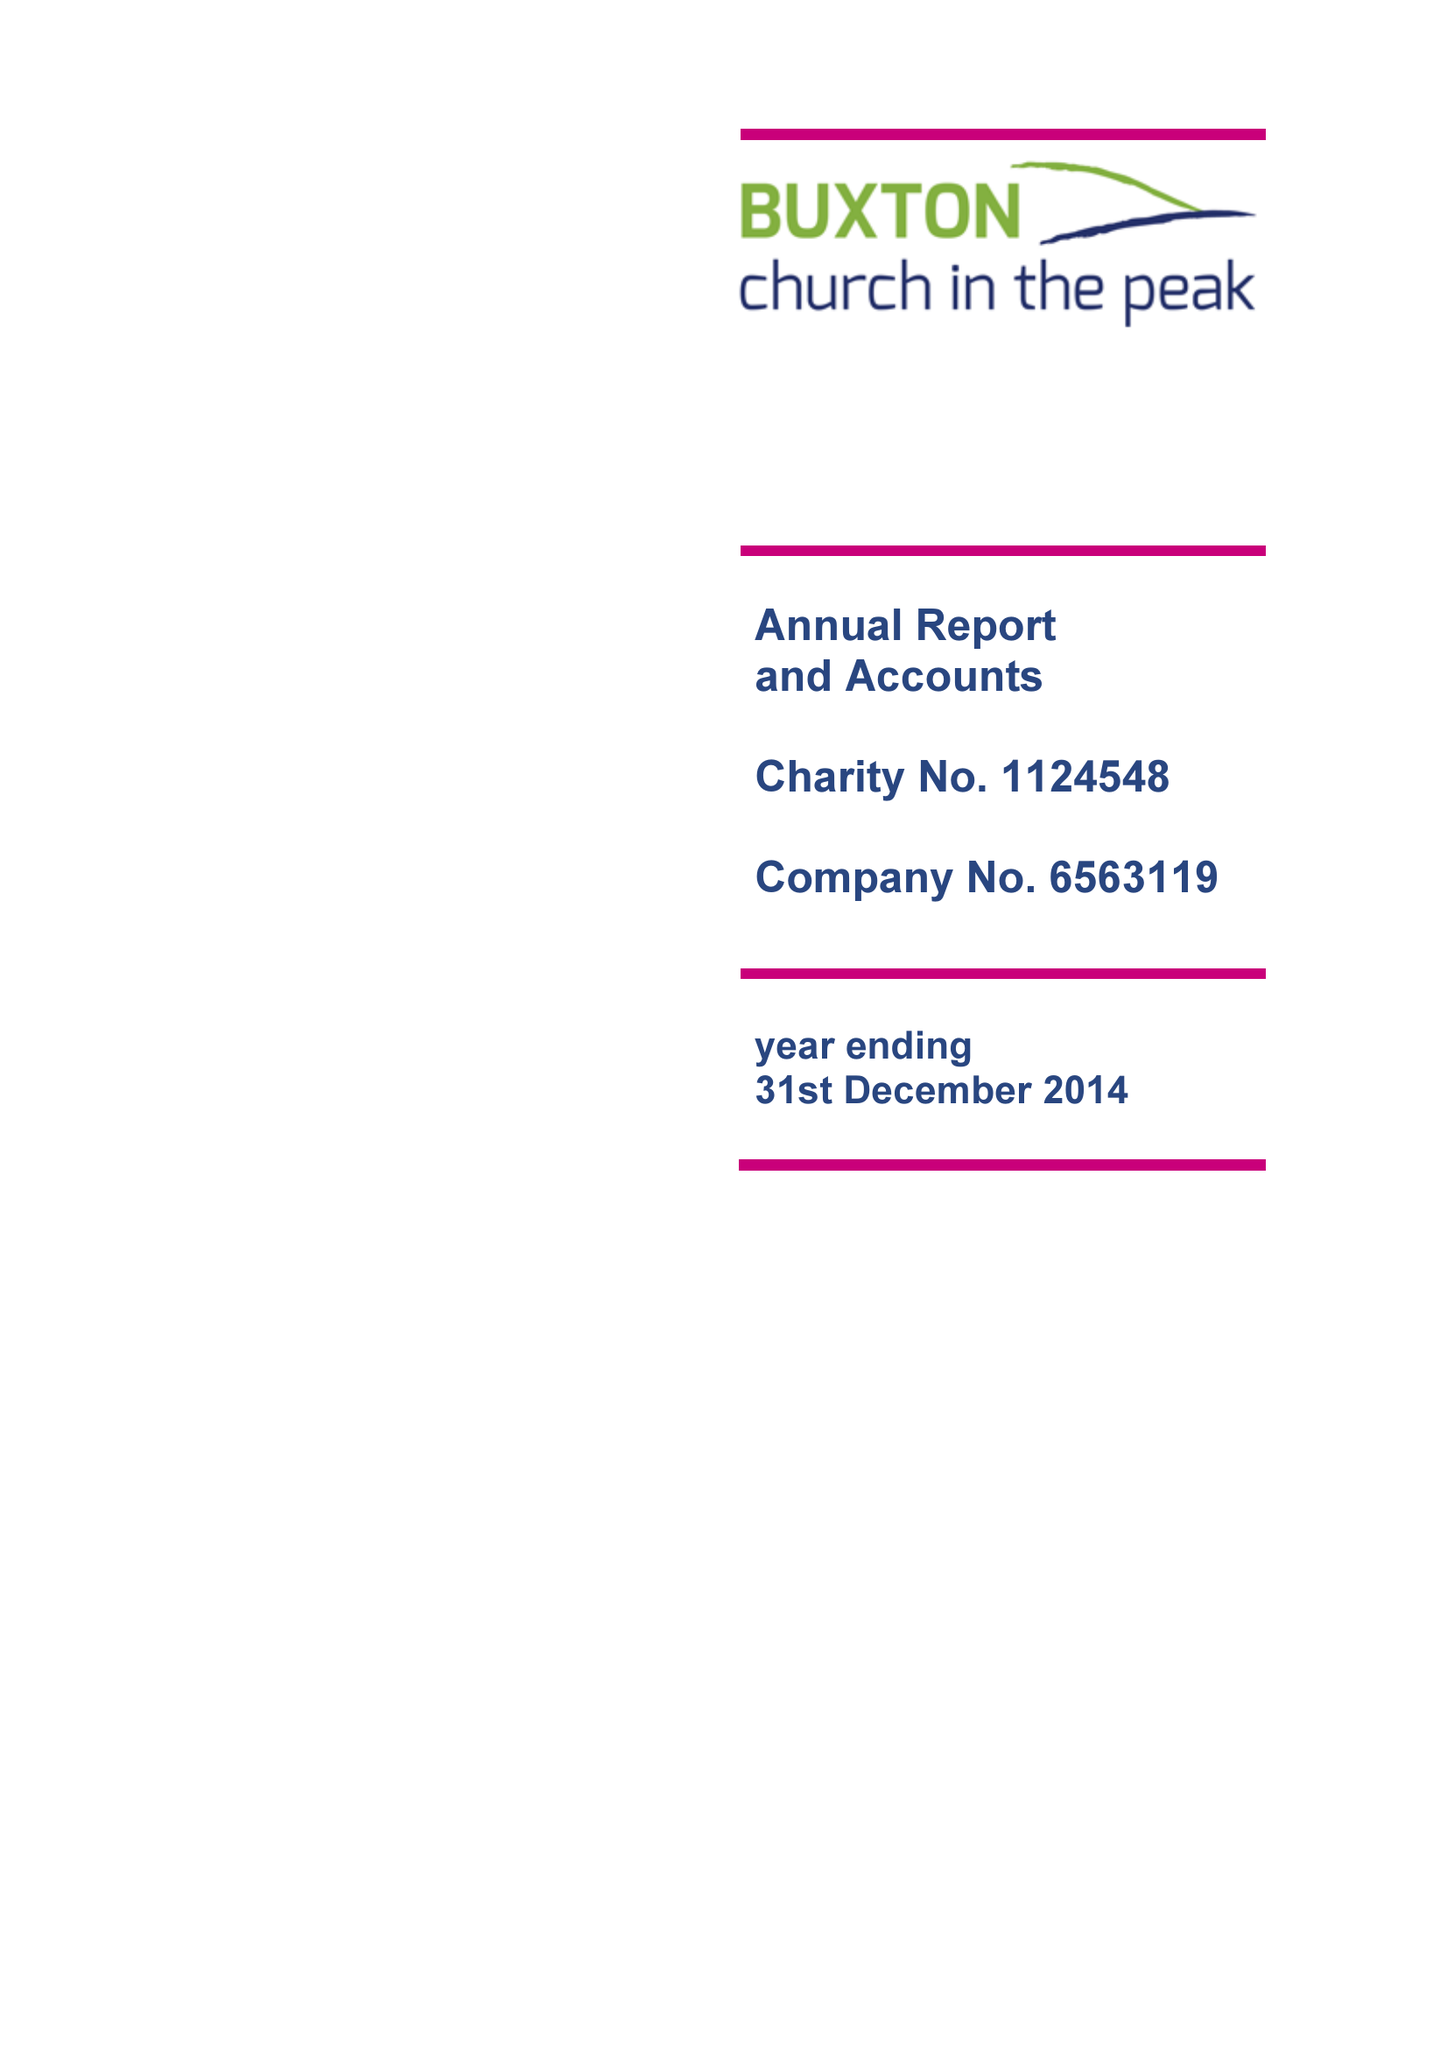What is the value for the address__post_town?
Answer the question using a single word or phrase. BUXTON 